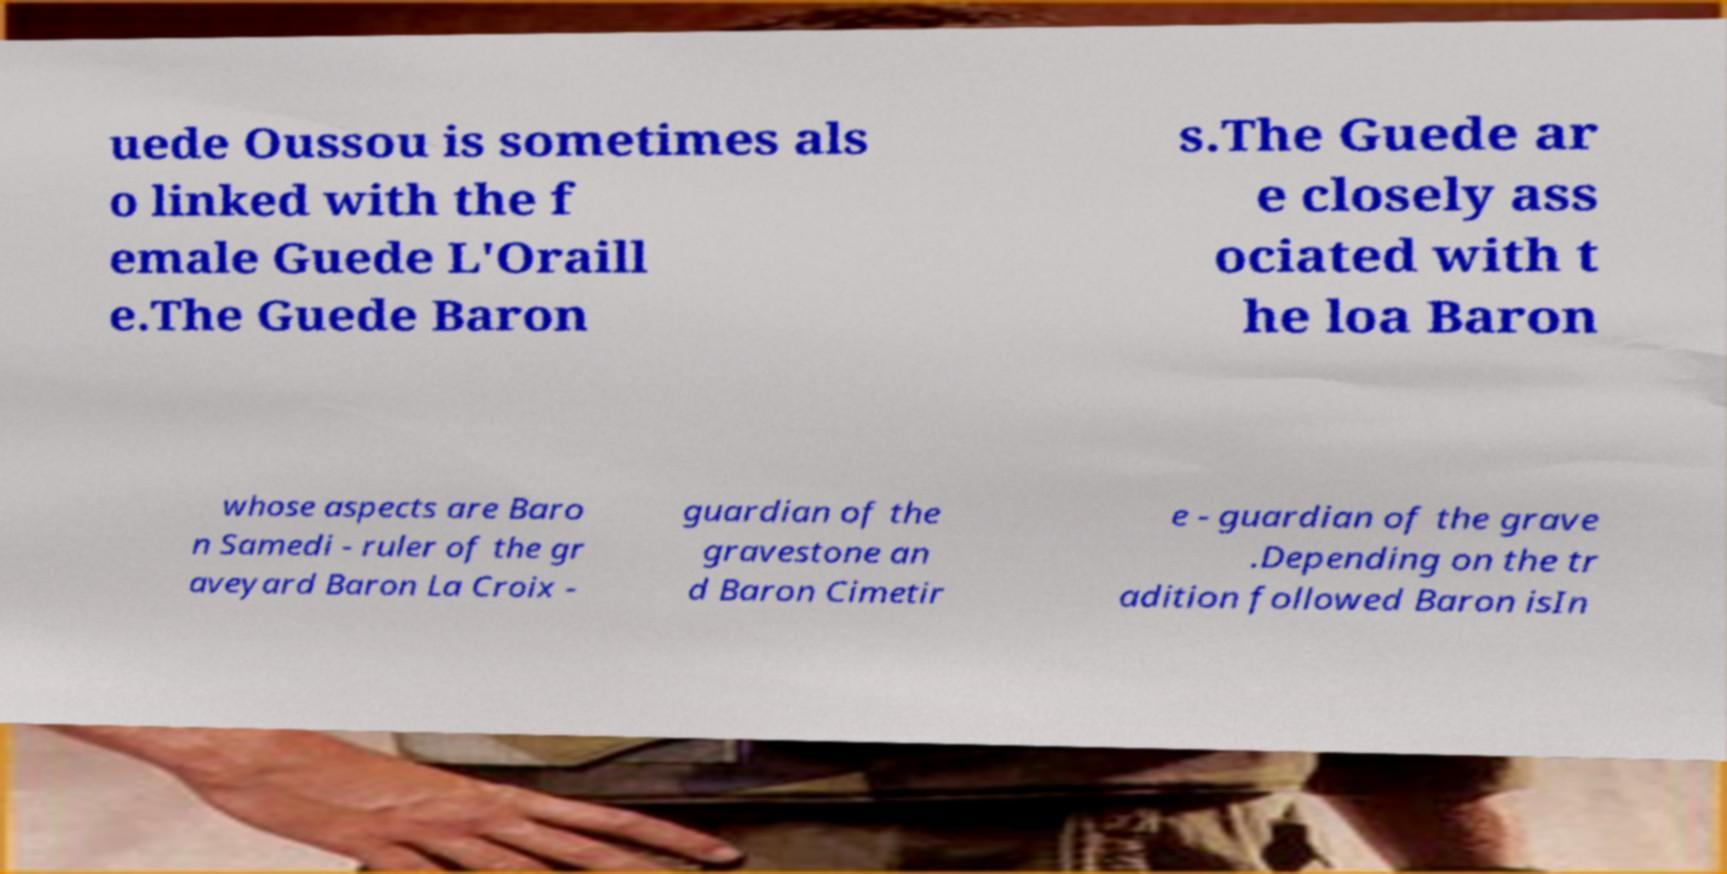Could you assist in decoding the text presented in this image and type it out clearly? uede Oussou is sometimes als o linked with the f emale Guede L'Oraill e.The Guede Baron s.The Guede ar e closely ass ociated with t he loa Baron whose aspects are Baro n Samedi - ruler of the gr aveyard Baron La Croix - guardian of the gravestone an d Baron Cimetir e - guardian of the grave .Depending on the tr adition followed Baron isIn 